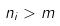Convert formula to latex. <formula><loc_0><loc_0><loc_500><loc_500>n _ { i } > m</formula> 